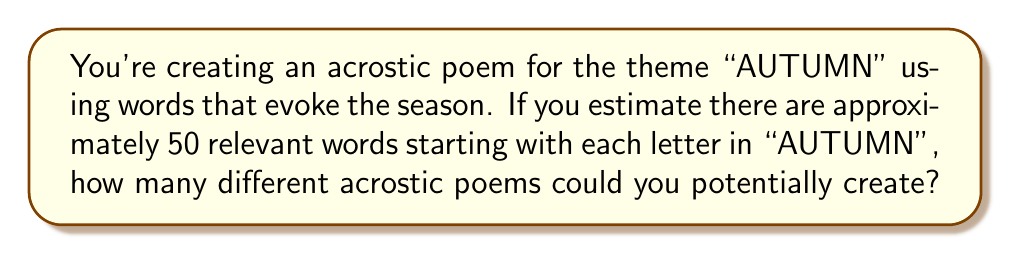Provide a solution to this math problem. Let's approach this step-by-step:

1) An acrostic poem for "AUTUMN" will have 6 lines, one for each letter in the word.

2) For each letter, we estimate there are 50 relevant words to choose from.

3) This scenario represents a combination problem where we're making independent choices for each line.

4) For each letter, we have 50 choices, and this is repeated for all 6 letters.

5) When we have a series of independent choices, we multiply the number of options for each choice.

6) Therefore, the total number of possible acrostic poems is:

   $$50 \times 50 \times 50 \times 50 \times 50 \times 50 = 50^6$$

7) Let's calculate this:
   $$50^6 = 15,625,000,000$$

Thus, there are 15,625,000,000 different acrostic poems that could potentially be created for the theme "AUTUMN" under these conditions.
Answer: $50^6 = 15,625,000,000$ 